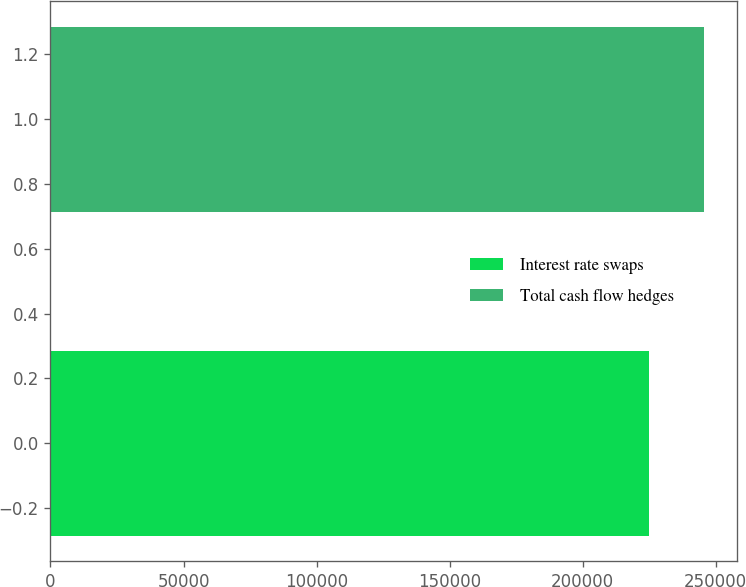Convert chart to OTSL. <chart><loc_0><loc_0><loc_500><loc_500><bar_chart><fcel>Interest rate swaps<fcel>Total cash flow hedges<nl><fcel>225000<fcel>245674<nl></chart> 